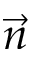<formula> <loc_0><loc_0><loc_500><loc_500>\vec { n }</formula> 